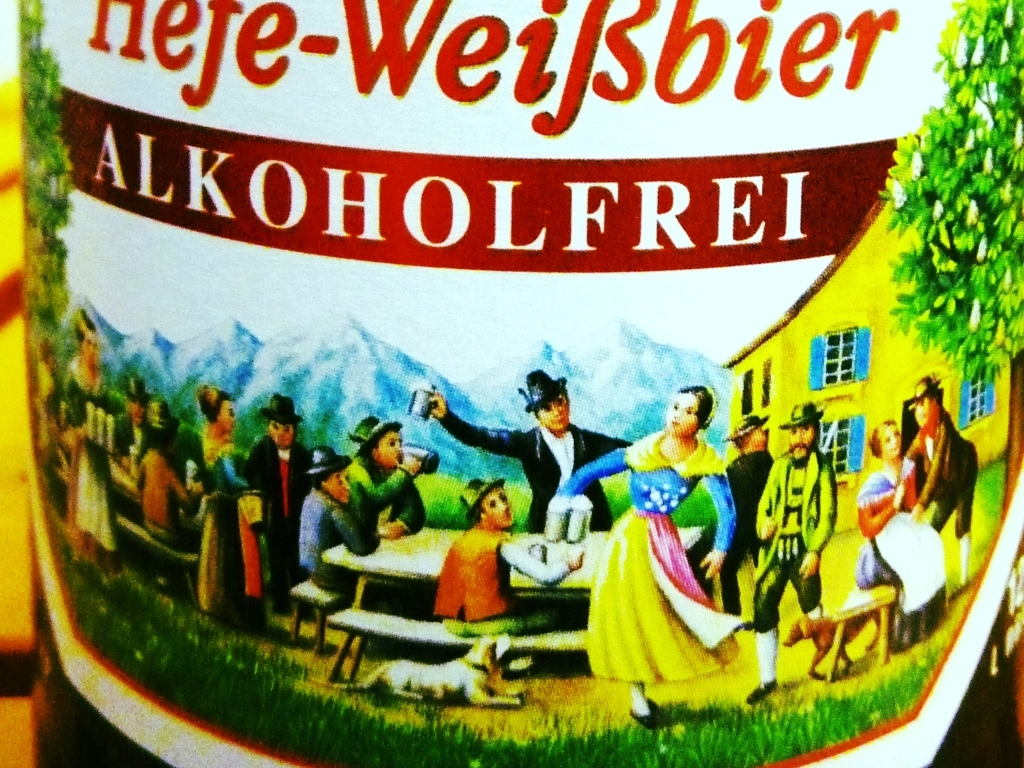The label mentions 'ALKOHOLFREI.' Can you explain what that means and why it might be significant? The term 'ALKOHOLFREI' on the label means 'alcohol-free' in German. This is significant because it indicates that the beer contains minimal or no alcohol, catering to those who wish to enjoy the taste of beer without the intoxicating effects. Alcohol-free beers are popular among people who are driving, pregnant, or abstaining from alcohol for health or personal reasons. It allows more people to participate in the social aspects of beer culture while maintaining their individual preferences or restrictions. 